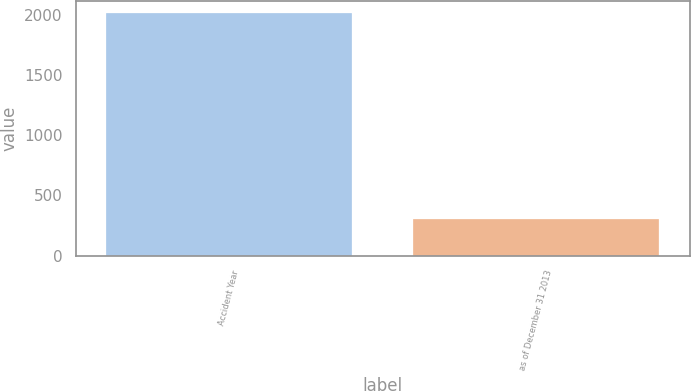<chart> <loc_0><loc_0><loc_500><loc_500><bar_chart><fcel>Accident Year<fcel>as of December 31 2013<nl><fcel>2012<fcel>304<nl></chart> 